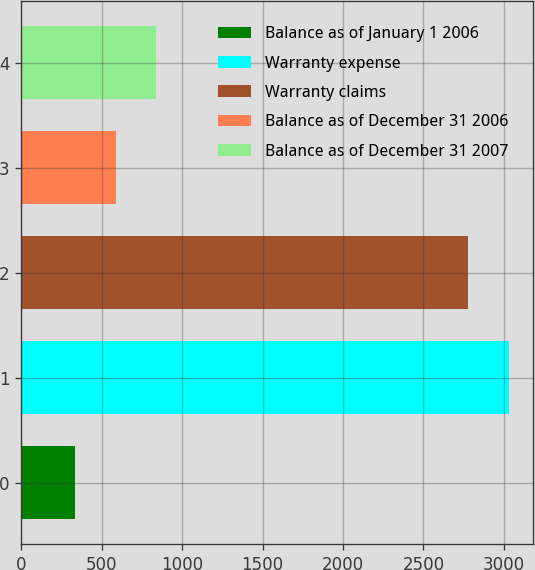Convert chart. <chart><loc_0><loc_0><loc_500><loc_500><bar_chart><fcel>Balance as of January 1 2006<fcel>Warranty expense<fcel>Warranty claims<fcel>Balance as of December 31 2006<fcel>Balance as of December 31 2007<nl><fcel>335<fcel>3029.8<fcel>2778<fcel>586.8<fcel>838.6<nl></chart> 